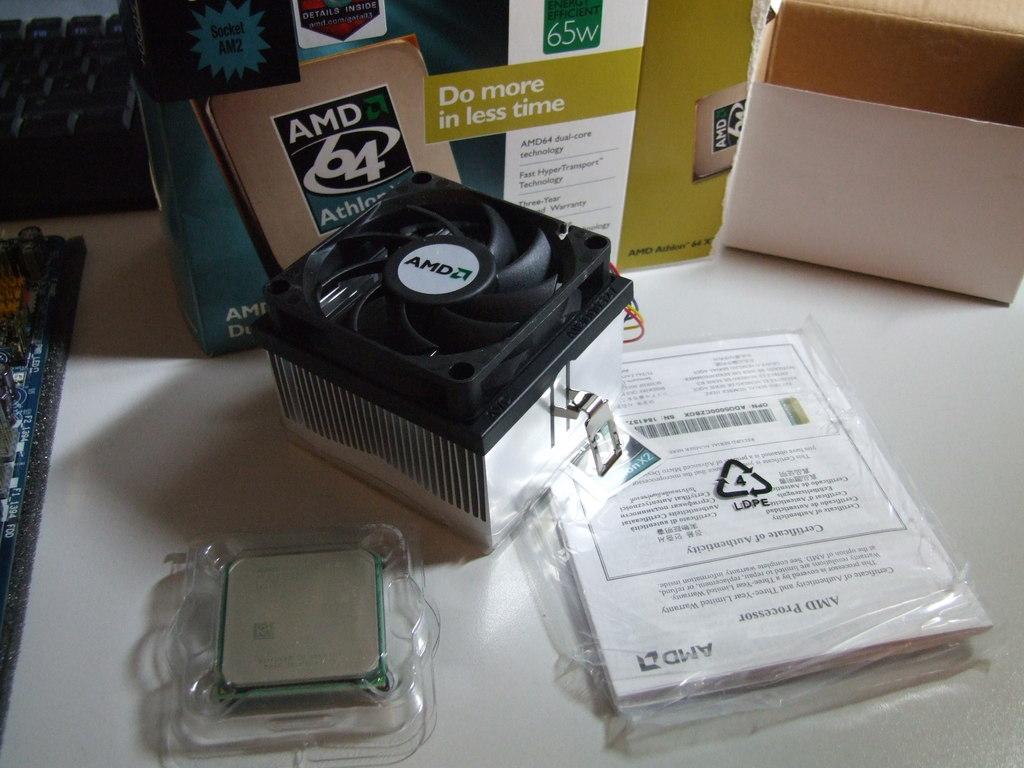What's the number under the company name?
Offer a terse response. 64. What company made this product?
Make the answer very short. Amd. 